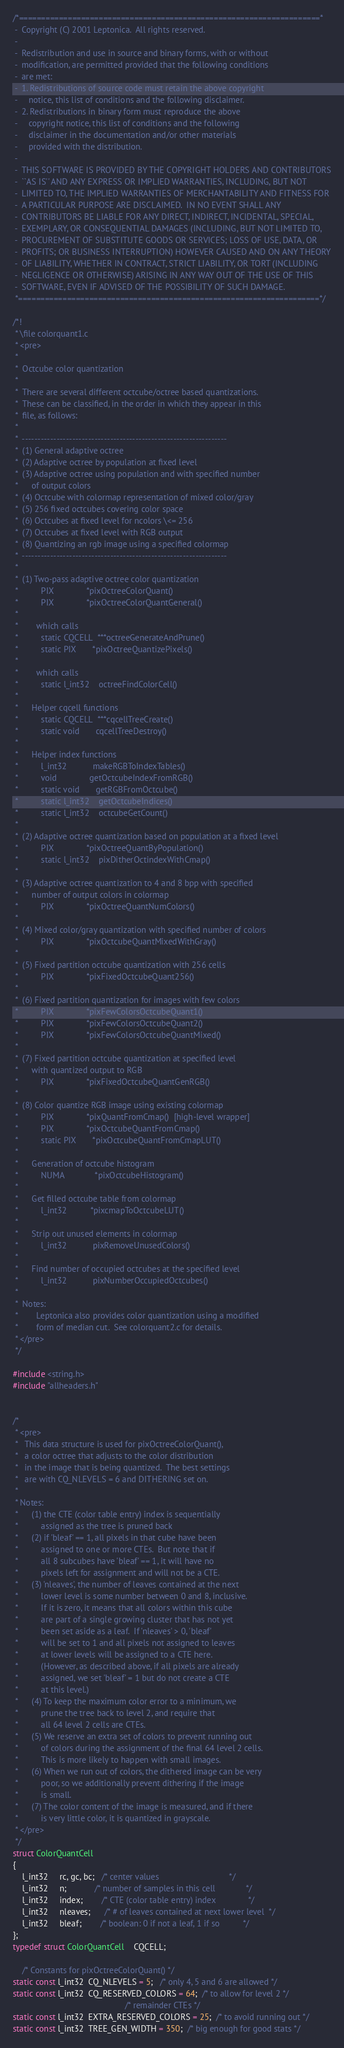Convert code to text. <code><loc_0><loc_0><loc_500><loc_500><_C_>/*====================================================================*
 -  Copyright (C) 2001 Leptonica.  All rights reserved.
 -
 -  Redistribution and use in source and binary forms, with or without
 -  modification, are permitted provided that the following conditions
 -  are met:
 -  1. Redistributions of source code must retain the above copyright
 -     notice, this list of conditions and the following disclaimer.
 -  2. Redistributions in binary form must reproduce the above
 -     copyright notice, this list of conditions and the following
 -     disclaimer in the documentation and/or other materials
 -     provided with the distribution.
 -
 -  THIS SOFTWARE IS PROVIDED BY THE COPYRIGHT HOLDERS AND CONTRIBUTORS
 -  ``AS IS'' AND ANY EXPRESS OR IMPLIED WARRANTIES, INCLUDING, BUT NOT
 -  LIMITED TO, THE IMPLIED WARRANTIES OF MERCHANTABILITY AND FITNESS FOR
 -  A PARTICULAR PURPOSE ARE DISCLAIMED.  IN NO EVENT SHALL ANY
 -  CONTRIBUTORS BE LIABLE FOR ANY DIRECT, INDIRECT, INCIDENTAL, SPECIAL,
 -  EXEMPLARY, OR CONSEQUENTIAL DAMAGES (INCLUDING, BUT NOT LIMITED TO,
 -  PROCUREMENT OF SUBSTITUTE GOODS OR SERVICES; LOSS OF USE, DATA, OR
 -  PROFITS; OR BUSINESS INTERRUPTION) HOWEVER CAUSED AND ON ANY THEORY
 -  OF LIABILITY, WHETHER IN CONTRACT, STRICT LIABILITY, OR TORT (INCLUDING
 -  NEGLIGENCE OR OTHERWISE) ARISING IN ANY WAY OUT OF THE USE OF THIS
 -  SOFTWARE, EVEN IF ADVISED OF THE POSSIBILITY OF SUCH DAMAGE.
 *====================================================================*/

/*!
 * \file colorquant1.c
 * <pre>
 *
 *  Octcube color quantization
 *
 *  There are several different octcube/octree based quantizations.
 *  These can be classified, in the order in which they appear in this
 *  file, as follows:
 *
 *  -----------------------------------------------------------------
 *  (1) General adaptive octree
 *  (2) Adaptive octree by population at fixed level
 *  (3) Adaptive octree using population and with specified number
 *      of output colors
 *  (4) Octcube with colormap representation of mixed color/gray
 *  (5) 256 fixed octcubes covering color space
 *  (6) Octcubes at fixed level for ncolors \<= 256
 *  (7) Octcubes at fixed level with RGB output
 *  (8) Quantizing an rgb image using a specified colormap
 *  -----------------------------------------------------------------
 *
 *  (1) Two-pass adaptive octree color quantization
 *          PIX              *pixOctreeColorQuant()
 *          PIX              *pixOctreeColorQuantGeneral()
 *
 *        which calls
 *          static CQCELL  ***octreeGenerateAndPrune()
 *          static PIX       *pixOctreeQuantizePixels()
 *
 *        which calls
 *          static l_int32    octreeFindColorCell()
 *
 *      Helper cqcell functions
 *          static CQCELL  ***cqcellTreeCreate()
 *          static void       cqcellTreeDestroy()
 *
 *      Helper index functions
 *          l_int32           makeRGBToIndexTables()
 *          void              getOctcubeIndexFromRGB()
 *          static void       getRGBFromOctcube()
 *          static l_int32    getOctcubeIndices()
 *          static l_int32    octcubeGetCount()
 *
 *  (2) Adaptive octree quantization based on population at a fixed level
 *          PIX              *pixOctreeQuantByPopulation()
 *          static l_int32    pixDitherOctindexWithCmap()
 *
 *  (3) Adaptive octree quantization to 4 and 8 bpp with specified
 *      number of output colors in colormap
 *          PIX              *pixOctreeQuantNumColors()
 *
 *  (4) Mixed color/gray quantization with specified number of colors
 *          PIX              *pixOctcubeQuantMixedWithGray()
 *
 *  (5) Fixed partition octcube quantization with 256 cells
 *          PIX              *pixFixedOctcubeQuant256()
 *
 *  (6) Fixed partition quantization for images with few colors
 *          PIX              *pixFewColorsOctcubeQuant1()
 *          PIX              *pixFewColorsOctcubeQuant2()
 *          PIX              *pixFewColorsOctcubeQuantMixed()
 *
 *  (7) Fixed partition octcube quantization at specified level
 *      with quantized output to RGB
 *          PIX              *pixFixedOctcubeQuantGenRGB()
 *
 *  (8) Color quantize RGB image using existing colormap
 *          PIX              *pixQuantFromCmap()  [high-level wrapper]
 *          PIX              *pixOctcubeQuantFromCmap()
 *          static PIX       *pixOctcubeQuantFromCmapLUT()
 *
 *      Generation of octcube histogram
 *          NUMA             *pixOctcubeHistogram()
 *
 *      Get filled octcube table from colormap
 *          l_int32          *pixcmapToOctcubeLUT()
 *
 *      Strip out unused elements in colormap
 *          l_int32           pixRemoveUnusedColors()
 *
 *      Find number of occupied octcubes at the specified level
 *          l_int32           pixNumberOccupiedOctcubes()
 *
 *  Notes:
 *        Leptonica also provides color quantization using a modified
 *        form of median cut.  See colorquant2.c for details.
 * </pre>
 */

#include <string.h>
#include "allheaders.h"


/*
 * <pre>
 *   This data structure is used for pixOctreeColorQuant(),
 *   a color octree that adjusts to the color distribution
 *   in the image that is being quantized.  The best settings
 *   are with CQ_NLEVELS = 6 and DITHERING set on.
 *
 * Notes:
 *      (1) the CTE (color table entry) index is sequentially
 *          assigned as the tree is pruned back
 *      (2) if 'bleaf' == 1, all pixels in that cube have been
 *          assigned to one or more CTEs.  But note that if
 *          all 8 subcubes have 'bleaf' == 1, it will have no
 *          pixels left for assignment and will not be a CTE.
 *      (3) 'nleaves', the number of leaves contained at the next
 *          lower level is some number between 0 and 8, inclusive.
 *          If it is zero, it means that all colors within this cube
 *          are part of a single growing cluster that has not yet
 *          been set aside as a leaf.  If 'nleaves' > 0, 'bleaf'
 *          will be set to 1 and all pixels not assigned to leaves
 *          at lower levels will be assigned to a CTE here.
 *          (However, as described above, if all pixels are already
 *          assigned, we set 'bleaf' = 1 but do not create a CTE
 *          at this level.)
 *      (4) To keep the maximum color error to a minimum, we
 *          prune the tree back to level 2, and require that
 *          all 64 level 2 cells are CTEs.
 *      (5) We reserve an extra set of colors to prevent running out
 *          of colors during the assignment of the final 64 level 2 cells.
 *          This is more likely to happen with small images.
 *      (6) When we run out of colors, the dithered image can be very
 *          poor, so we additionally prevent dithering if the image
 *          is small.
 *      (7) The color content of the image is measured, and if there
 *          is very little color, it is quantized in grayscale.
 * </pre>
 */
struct ColorQuantCell
{
    l_int32     rc, gc, bc;   /* center values                              */
    l_int32     n;            /* number of samples in this cell             */
    l_int32     index;        /* CTE (color table entry) index              */
    l_int32     nleaves;      /* # of leaves contained at next lower level  */
    l_int32     bleaf;        /* boolean: 0 if not a leaf, 1 if so          */
};
typedef struct ColorQuantCell    CQCELL;

    /* Constants for pixOctreeColorQuant() */
static const l_int32  CQ_NLEVELS = 5;   /* only 4, 5 and 6 are allowed */
static const l_int32  CQ_RESERVED_COLORS = 64;  /* to allow for level 2 */
                                                /* remainder CTEs */
static const l_int32  EXTRA_RESERVED_COLORS = 25;  /* to avoid running out */
static const l_int32  TREE_GEN_WIDTH = 350;  /* big enough for good stats */</code> 